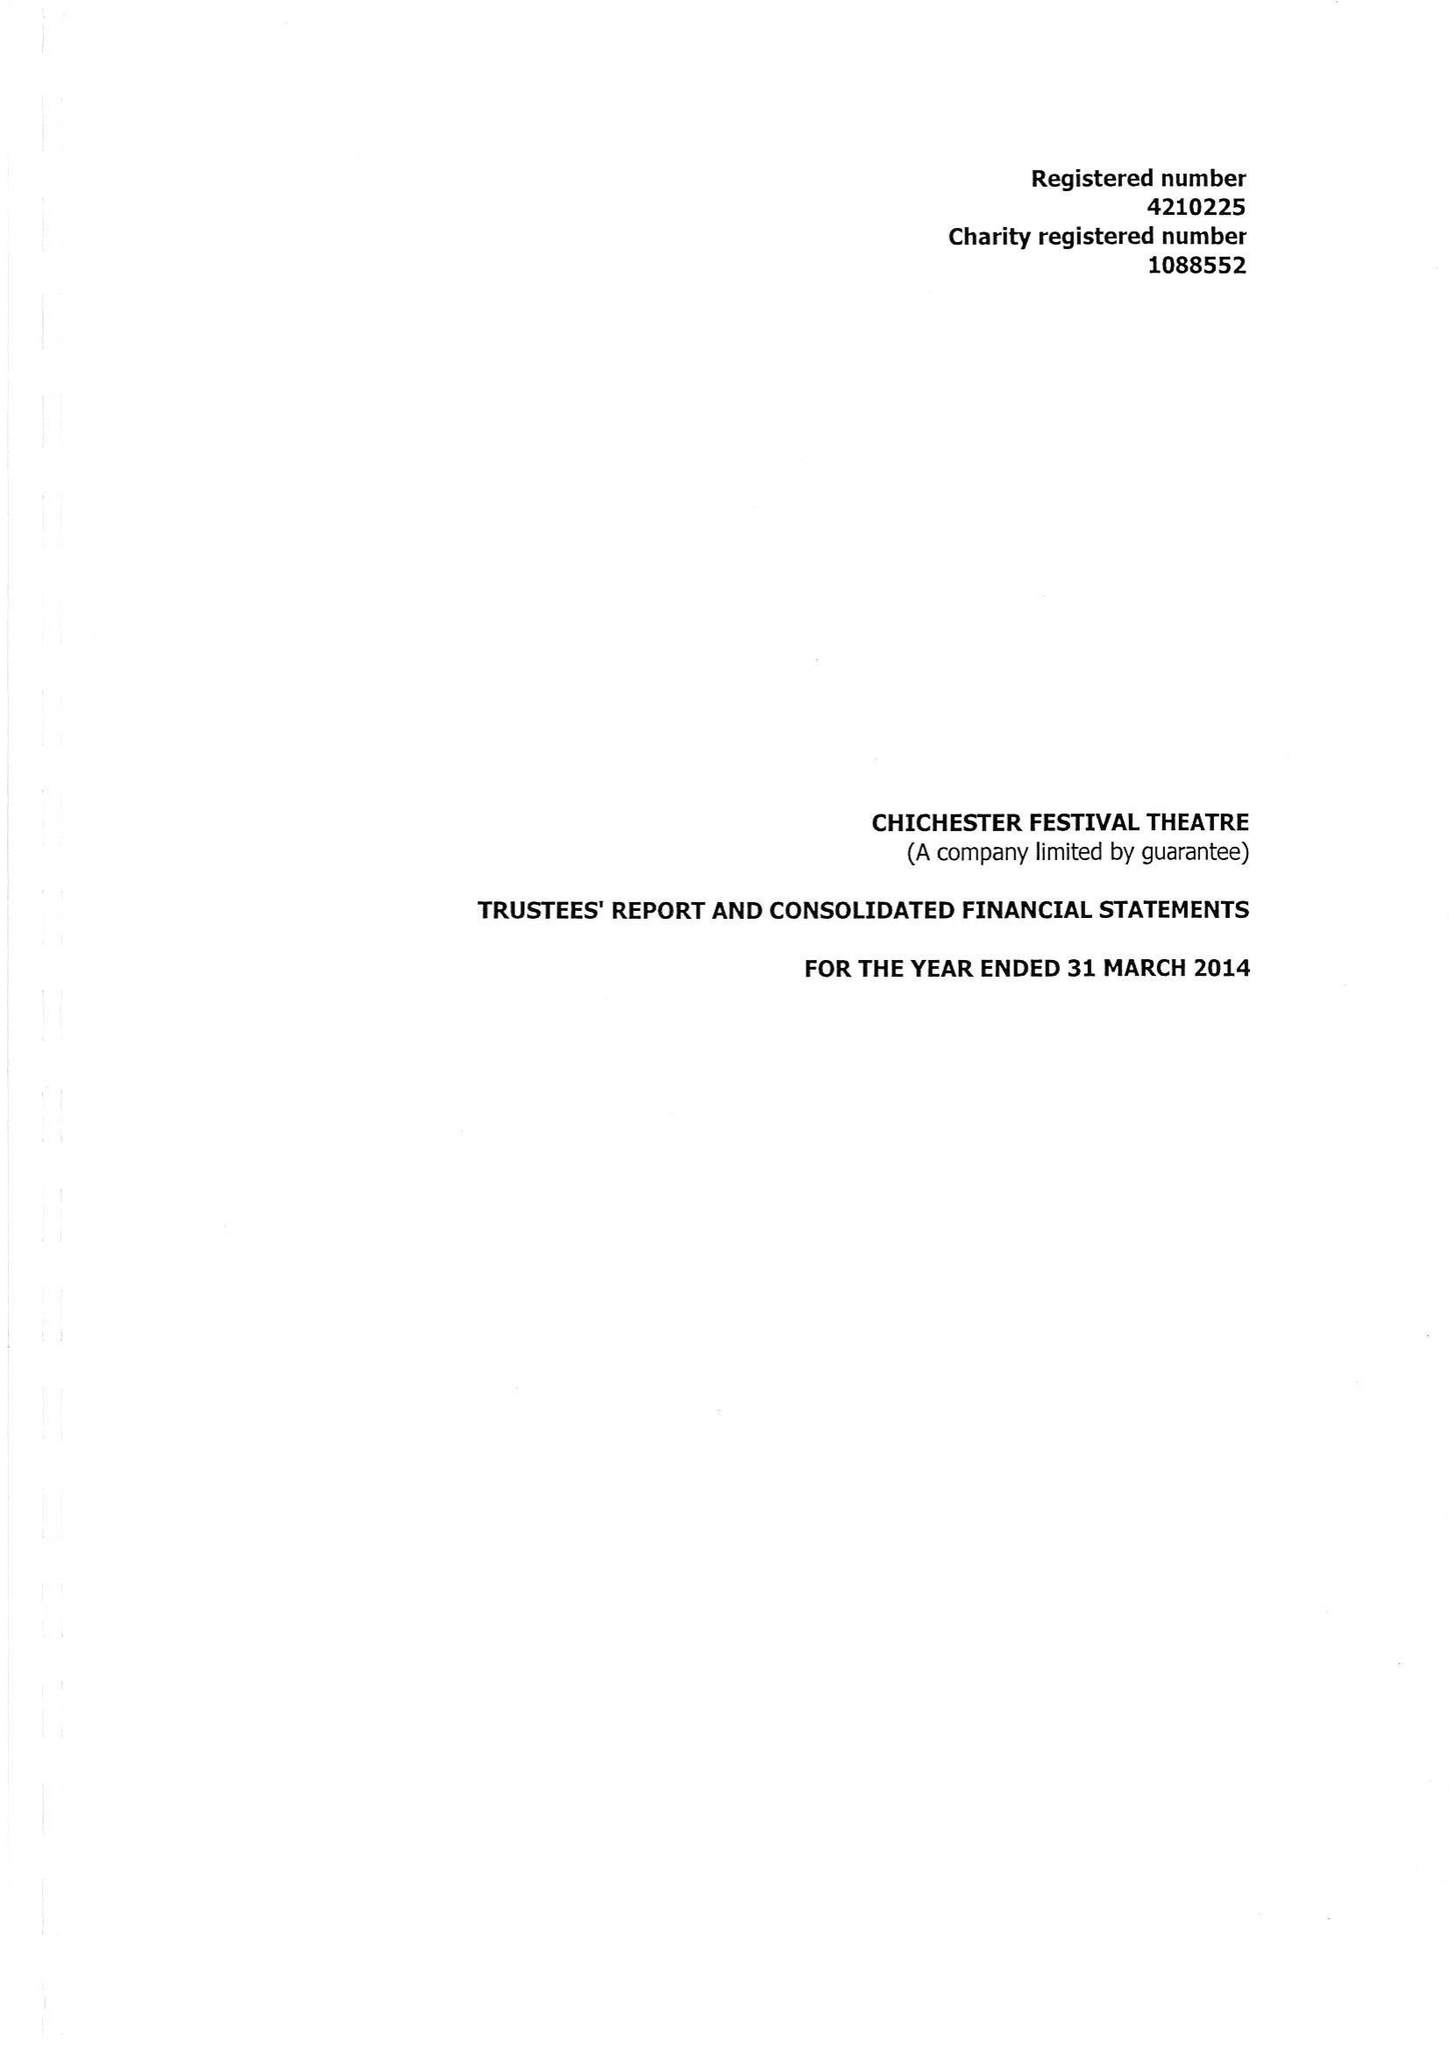What is the value for the address__street_line?
Answer the question using a single word or phrase. OAKLANDS PARK 